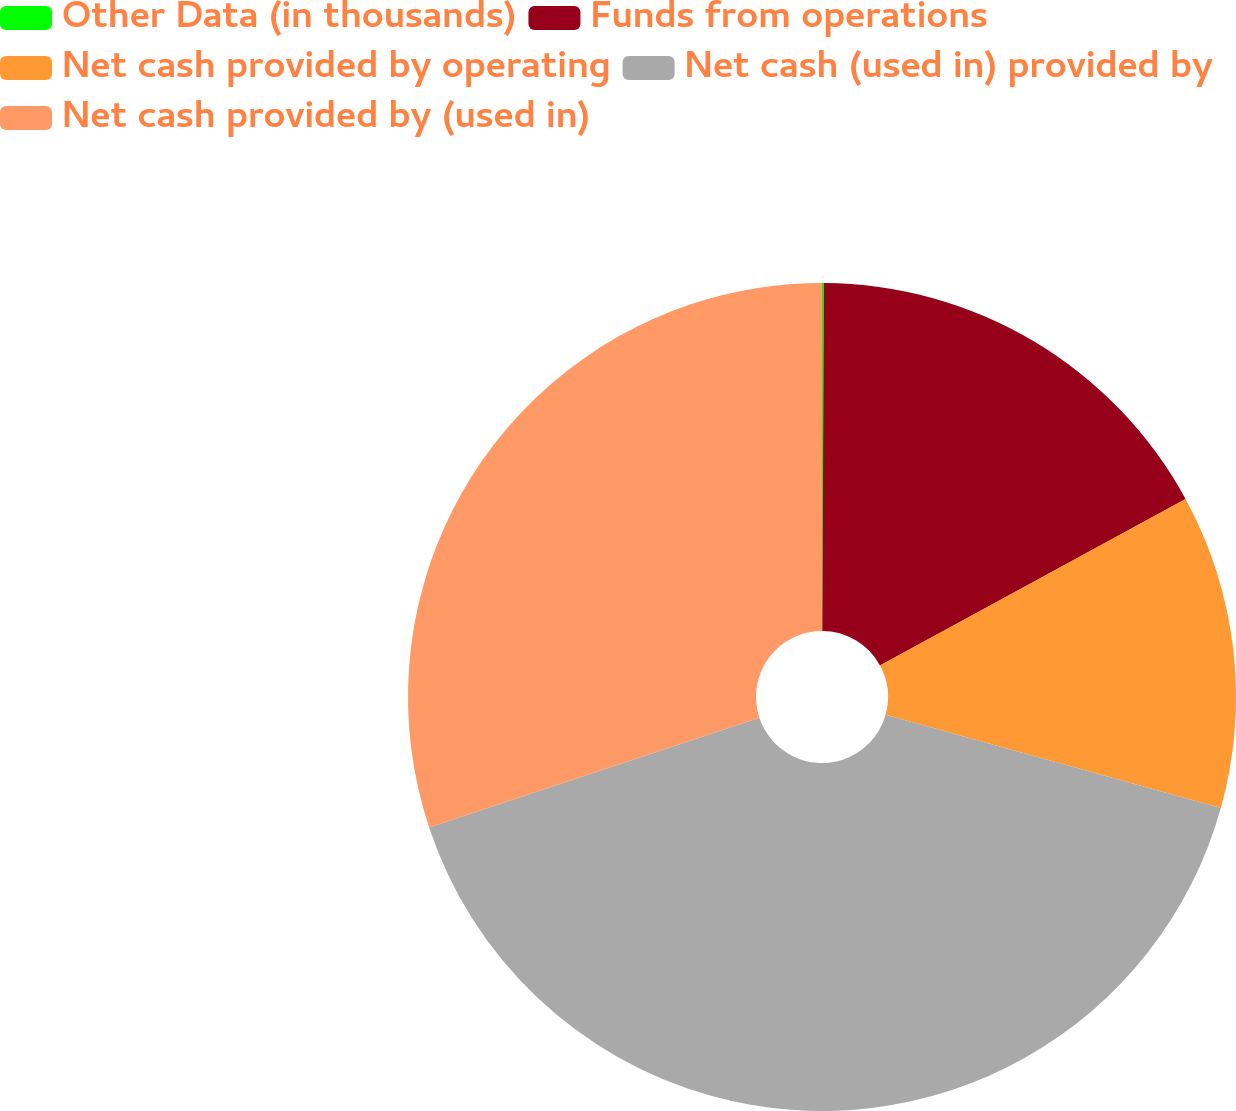Convert chart. <chart><loc_0><loc_0><loc_500><loc_500><pie_chart><fcel>Other Data (in thousands)<fcel>Funds from operations<fcel>Net cash provided by operating<fcel>Net cash (used in) provided by<fcel>Net cash provided by (used in)<nl><fcel>0.07%<fcel>16.99%<fcel>12.26%<fcel>40.57%<fcel>30.1%<nl></chart> 